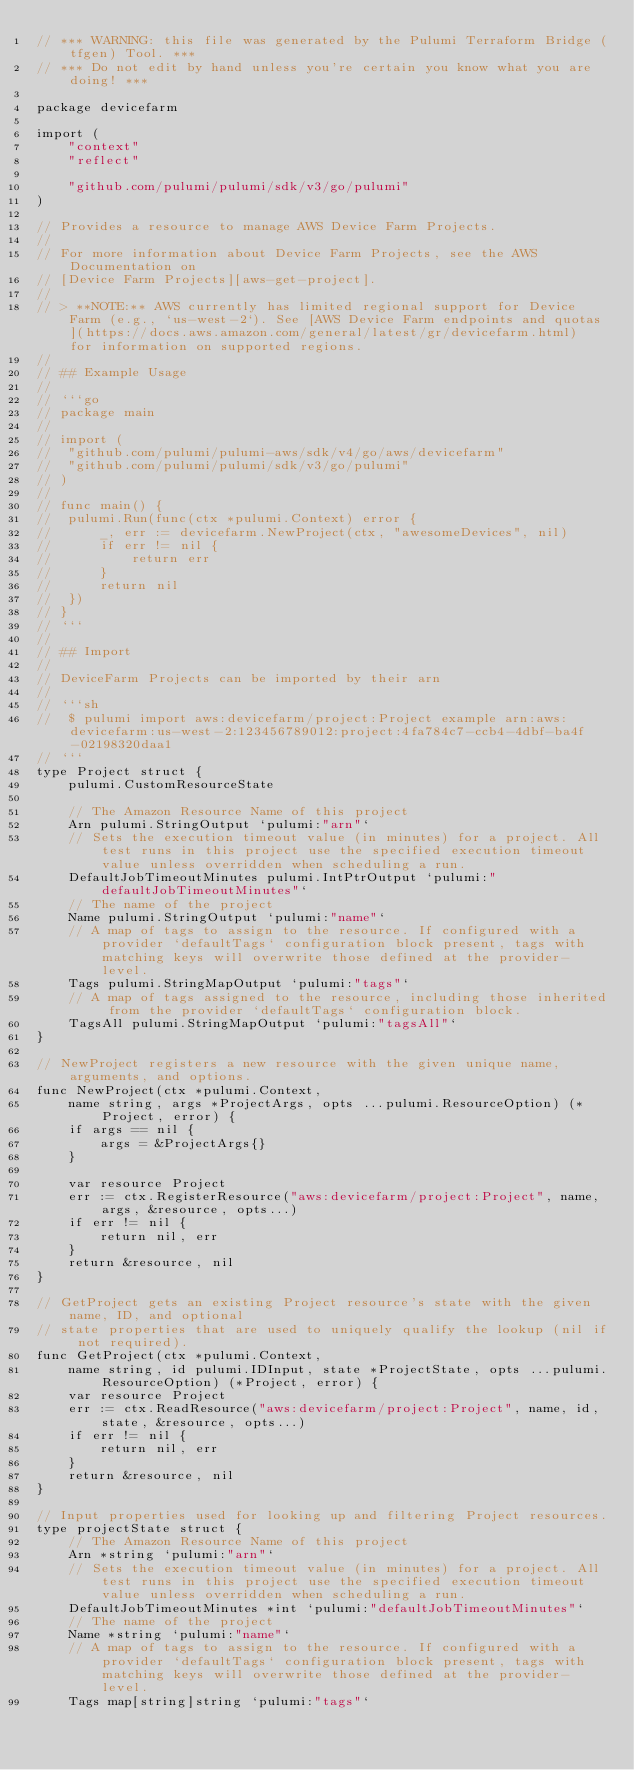Convert code to text. <code><loc_0><loc_0><loc_500><loc_500><_Go_>// *** WARNING: this file was generated by the Pulumi Terraform Bridge (tfgen) Tool. ***
// *** Do not edit by hand unless you're certain you know what you are doing! ***

package devicefarm

import (
	"context"
	"reflect"

	"github.com/pulumi/pulumi/sdk/v3/go/pulumi"
)

// Provides a resource to manage AWS Device Farm Projects.
//
// For more information about Device Farm Projects, see the AWS Documentation on
// [Device Farm Projects][aws-get-project].
//
// > **NOTE:** AWS currently has limited regional support for Device Farm (e.g., `us-west-2`). See [AWS Device Farm endpoints and quotas](https://docs.aws.amazon.com/general/latest/gr/devicefarm.html) for information on supported regions.
//
// ## Example Usage
//
// ```go
// package main
//
// import (
// 	"github.com/pulumi/pulumi-aws/sdk/v4/go/aws/devicefarm"
// 	"github.com/pulumi/pulumi/sdk/v3/go/pulumi"
// )
//
// func main() {
// 	pulumi.Run(func(ctx *pulumi.Context) error {
// 		_, err := devicefarm.NewProject(ctx, "awesomeDevices", nil)
// 		if err != nil {
// 			return err
// 		}
// 		return nil
// 	})
// }
// ```
//
// ## Import
//
// DeviceFarm Projects can be imported by their arn
//
// ```sh
//  $ pulumi import aws:devicefarm/project:Project example arn:aws:devicefarm:us-west-2:123456789012:project:4fa784c7-ccb4-4dbf-ba4f-02198320daa1
// ```
type Project struct {
	pulumi.CustomResourceState

	// The Amazon Resource Name of this project
	Arn pulumi.StringOutput `pulumi:"arn"`
	// Sets the execution timeout value (in minutes) for a project. All test runs in this project use the specified execution timeout value unless overridden when scheduling a run.
	DefaultJobTimeoutMinutes pulumi.IntPtrOutput `pulumi:"defaultJobTimeoutMinutes"`
	// The name of the project
	Name pulumi.StringOutput `pulumi:"name"`
	// A map of tags to assign to the resource. If configured with a provider `defaultTags` configuration block present, tags with matching keys will overwrite those defined at the provider-level.
	Tags pulumi.StringMapOutput `pulumi:"tags"`
	// A map of tags assigned to the resource, including those inherited from the provider `defaultTags` configuration block.
	TagsAll pulumi.StringMapOutput `pulumi:"tagsAll"`
}

// NewProject registers a new resource with the given unique name, arguments, and options.
func NewProject(ctx *pulumi.Context,
	name string, args *ProjectArgs, opts ...pulumi.ResourceOption) (*Project, error) {
	if args == nil {
		args = &ProjectArgs{}
	}

	var resource Project
	err := ctx.RegisterResource("aws:devicefarm/project:Project", name, args, &resource, opts...)
	if err != nil {
		return nil, err
	}
	return &resource, nil
}

// GetProject gets an existing Project resource's state with the given name, ID, and optional
// state properties that are used to uniquely qualify the lookup (nil if not required).
func GetProject(ctx *pulumi.Context,
	name string, id pulumi.IDInput, state *ProjectState, opts ...pulumi.ResourceOption) (*Project, error) {
	var resource Project
	err := ctx.ReadResource("aws:devicefarm/project:Project", name, id, state, &resource, opts...)
	if err != nil {
		return nil, err
	}
	return &resource, nil
}

// Input properties used for looking up and filtering Project resources.
type projectState struct {
	// The Amazon Resource Name of this project
	Arn *string `pulumi:"arn"`
	// Sets the execution timeout value (in minutes) for a project. All test runs in this project use the specified execution timeout value unless overridden when scheduling a run.
	DefaultJobTimeoutMinutes *int `pulumi:"defaultJobTimeoutMinutes"`
	// The name of the project
	Name *string `pulumi:"name"`
	// A map of tags to assign to the resource. If configured with a provider `defaultTags` configuration block present, tags with matching keys will overwrite those defined at the provider-level.
	Tags map[string]string `pulumi:"tags"`</code> 